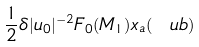<formula> <loc_0><loc_0><loc_500><loc_500>\frac { 1 } { 2 } \delta | u _ { 0 } | ^ { - 2 } F _ { 0 } ( M _ { 1 } ) x _ { a } ( \ u b )</formula> 